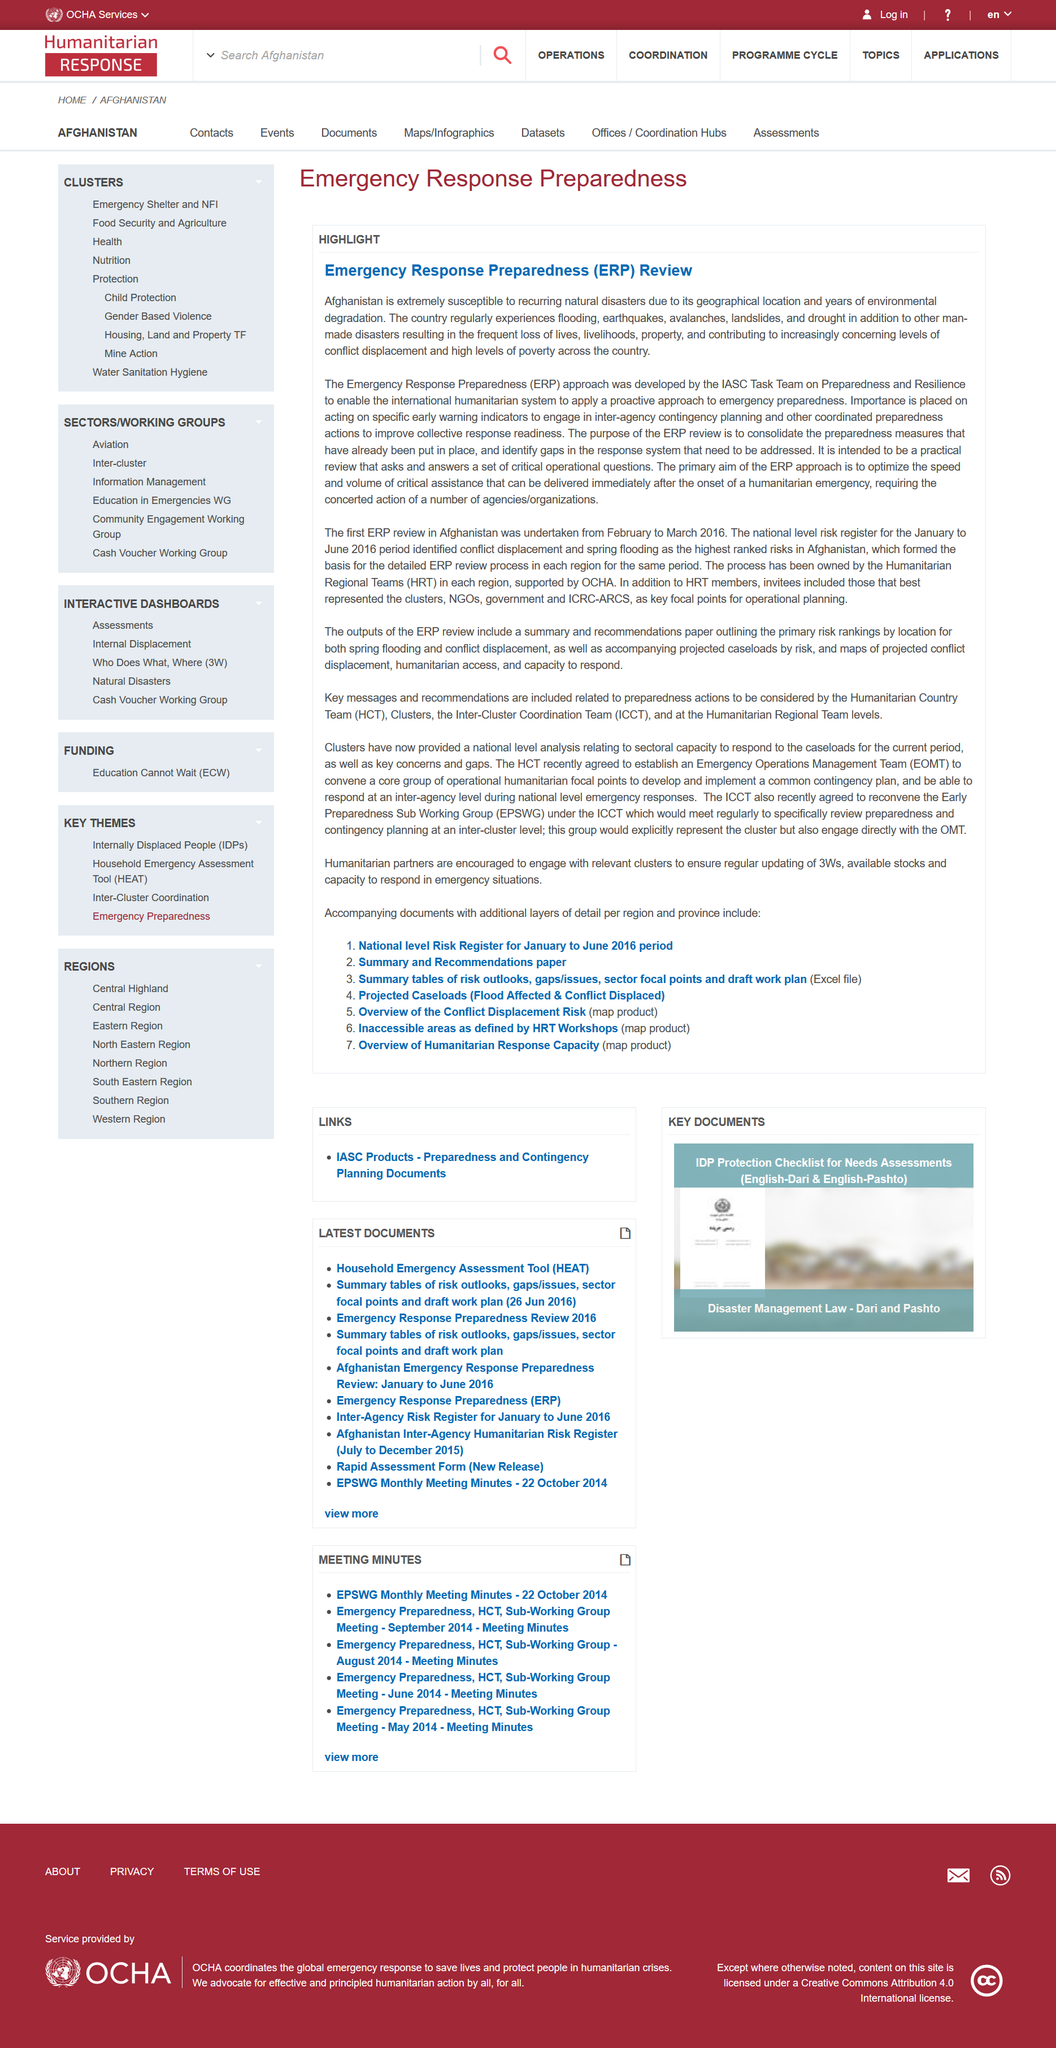Draw attention to some important aspects in this diagram. Afghanistan's geographical location and decades of environmental degradation have made the country extremely susceptible to recurring natural disasters. Afghanistan's vulnerability to natural disasters is a critical factor in emergency response preparedness, as discussed in relation to the country's susceptibility to natural disasters. The ERP approach was developed by the IASC Task Team on Preparedness and Resilience. 